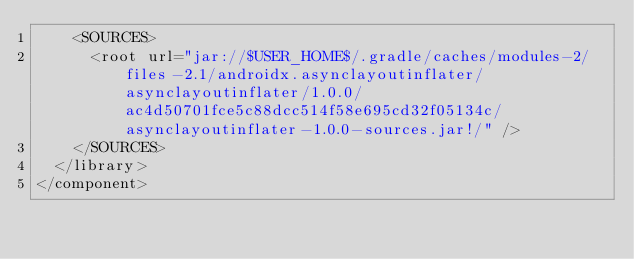Convert code to text. <code><loc_0><loc_0><loc_500><loc_500><_XML_>    <SOURCES>
      <root url="jar://$USER_HOME$/.gradle/caches/modules-2/files-2.1/androidx.asynclayoutinflater/asynclayoutinflater/1.0.0/ac4d50701fce5c88dcc514f58e695cd32f05134c/asynclayoutinflater-1.0.0-sources.jar!/" />
    </SOURCES>
  </library>
</component></code> 